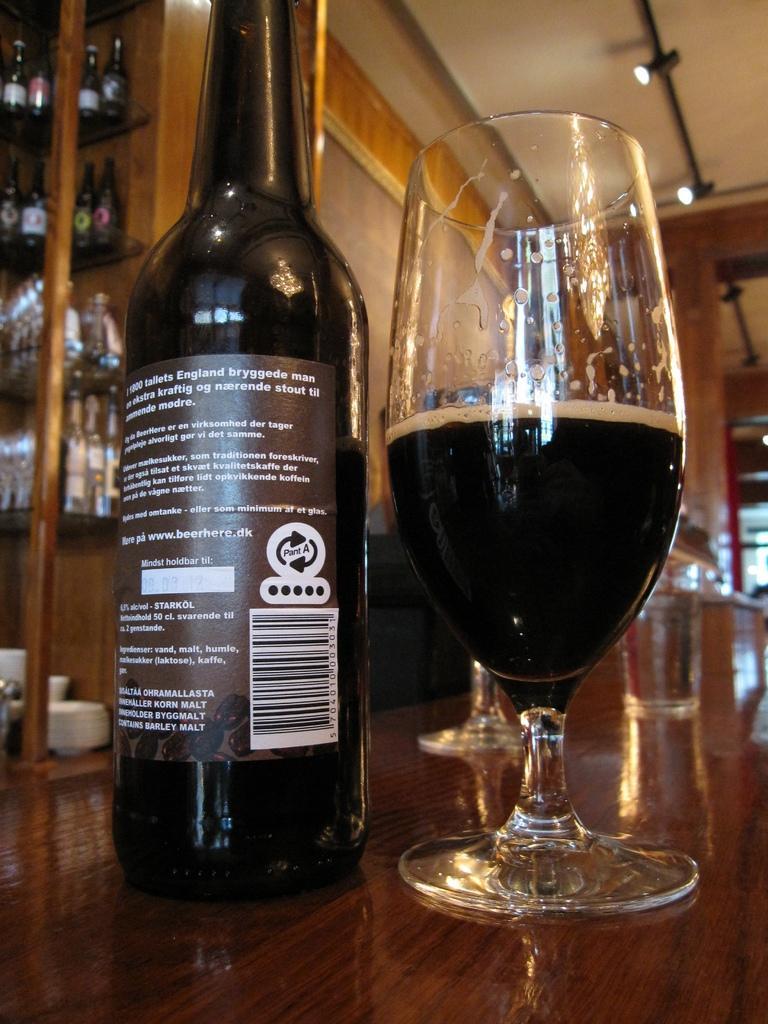Could you give a brief overview of what you see in this image? In this image there is a wine bottle at left side of this image and there is one glass at right side of this image,and there is a table at below of this image. There are some bottles are kept in table at left side of this image,and there is a wall in the background. There are some lights at top right corner of this image. 